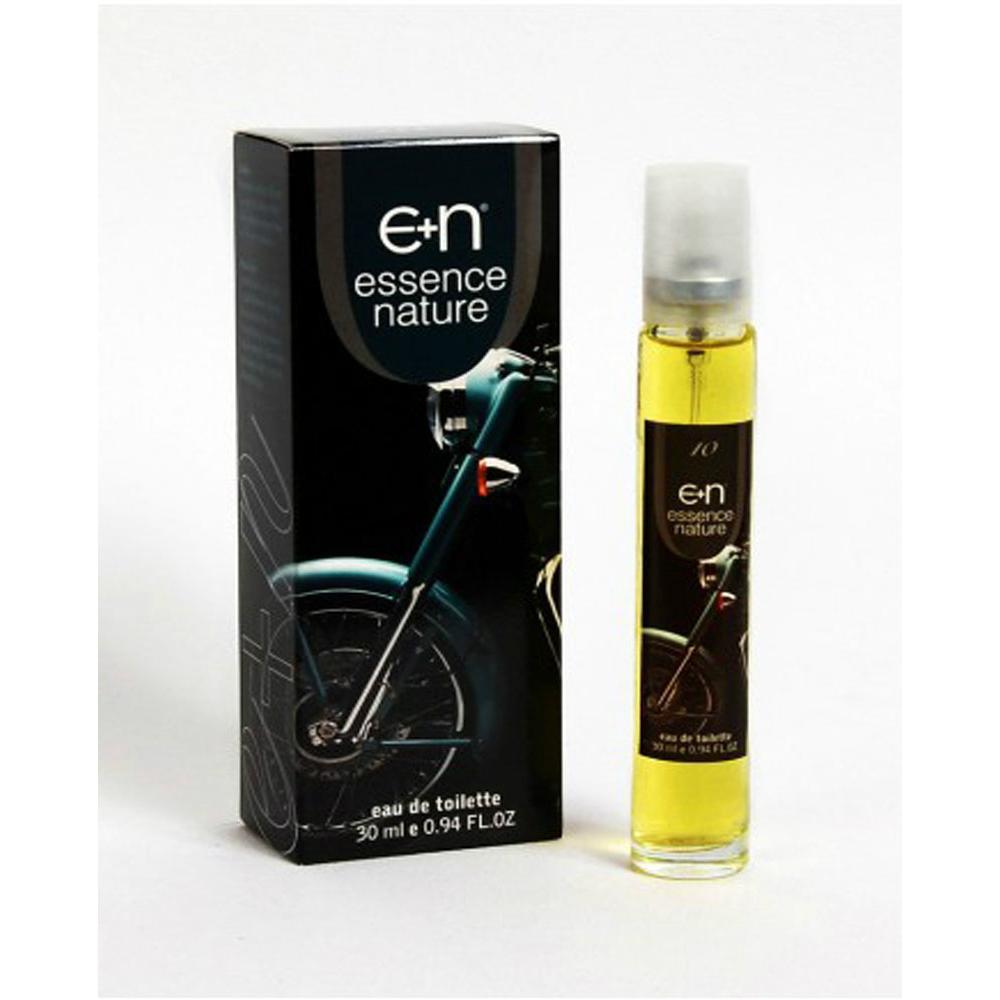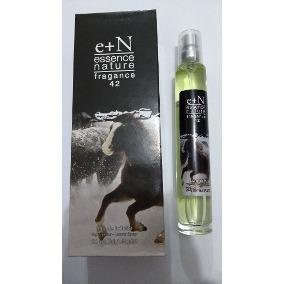The first image is the image on the left, the second image is the image on the right. For the images shown, is this caption "Two slender spray bottles with clear caps are shown to the right of their boxes." true? Answer yes or no. Yes. The first image is the image on the left, the second image is the image on the right. Given the left and right images, does the statement "There are two long cylindrical perfume bottles next to their packaging box." hold true? Answer yes or no. Yes. 